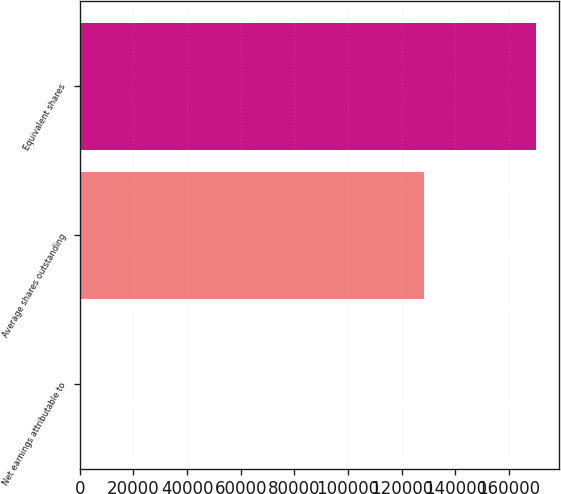Convert chart. <chart><loc_0><loc_0><loc_500><loc_500><bar_chart><fcel>Net earnings attributable to<fcel>Average shares outstanding<fcel>Equivalent shares<nl><fcel>3.2<fcel>128411<fcel>170004<nl></chart> 